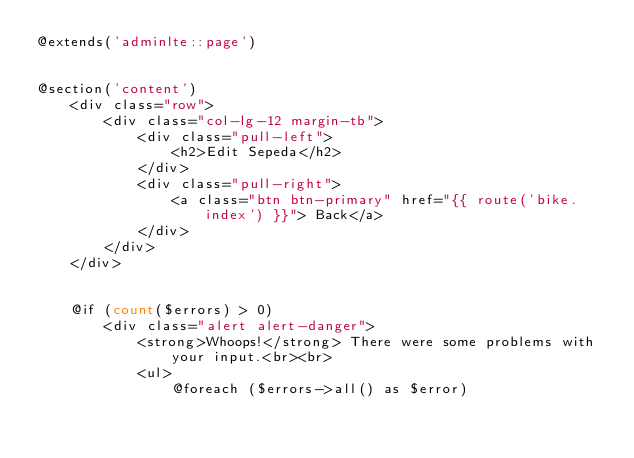Convert code to text. <code><loc_0><loc_0><loc_500><loc_500><_PHP_>@extends('adminlte::page')


@section('content')
    <div class="row">
        <div class="col-lg-12 margin-tb">
            <div class="pull-left">
                <h2>Edit Sepeda</h2>
            </div>
            <div class="pull-right">
                <a class="btn btn-primary" href="{{ route('bike.index') }}"> Back</a>
            </div>
        </div>
    </div>


    @if (count($errors) > 0)
        <div class="alert alert-danger">
            <strong>Whoops!</strong> There were some problems with your input.<br><br>
            <ul>
                @foreach ($errors->all() as $error)</code> 